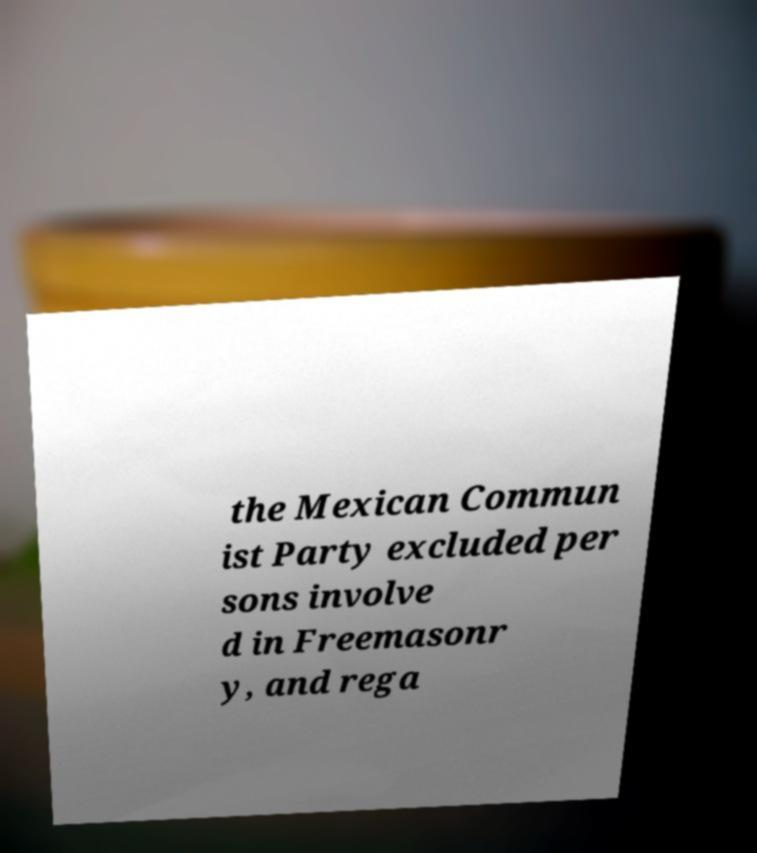Can you read and provide the text displayed in the image?This photo seems to have some interesting text. Can you extract and type it out for me? the Mexican Commun ist Party excluded per sons involve d in Freemasonr y, and rega 